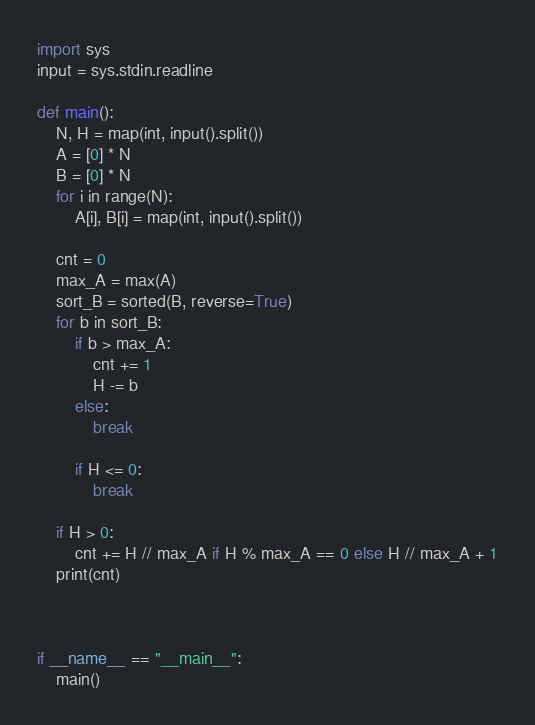Convert code to text. <code><loc_0><loc_0><loc_500><loc_500><_Python_>import sys
input = sys.stdin.readline

def main():
    N, H = map(int, input().split())
    A = [0] * N
    B = [0] * N
    for i in range(N):
        A[i], B[i] = map(int, input().split())

    cnt = 0
    max_A = max(A)
    sort_B = sorted(B, reverse=True)
    for b in sort_B:
        if b > max_A:
            cnt += 1
            H -= b
        else:
            break

        if H <= 0:
            break
    
    if H > 0:
        cnt += H // max_A if H % max_A == 0 else H // max_A + 1
    print(cnt)



if __name__ == "__main__":
    main()</code> 